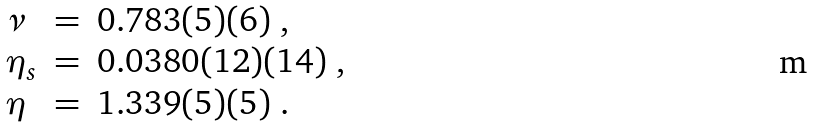<formula> <loc_0><loc_0><loc_500><loc_500>\begin{array} { l c l } \nu & = & 0 . 7 8 3 ( 5 ) ( 6 ) \ , \\ \eta _ { s } & = & 0 . 0 3 8 0 ( 1 2 ) ( 1 4 ) \ , \\ \eta & = & 1 . 3 3 9 ( 5 ) ( 5 ) \ . \end{array}</formula> 